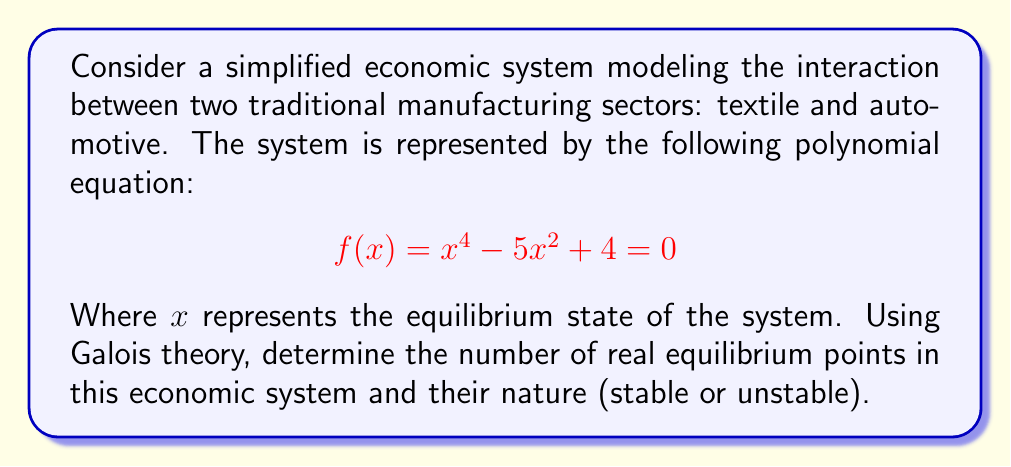Can you solve this math problem? To solve this problem using Galois theory, we'll follow these steps:

1) First, let's factor the polynomial:
   $$f(x) = x^4 - 5x^2 + 4 = (x^2 - 1)(x^2 - 4) = (x-1)(x+1)(x-2)(x+2)$$

2) The Galois group of this polynomial is a subgroup of $S_4$ (the symmetric group on 4 elements). Given the factorization, we can see that the Galois group is actually $C_2 \times C_2$, where $C_2$ is the cyclic group of order 2.

3) The fixed field of this Galois group is $\mathbb{Q}$, which means all roots are real and can be expressed using rational operations and square roots.

4) The roots of the polynomial are $x = \pm 1$ and $x = \pm 2$. These represent the equilibrium points of our economic system.

5) To determine stability, we need to consider the derivative of $f(x)$:
   $$f'(x) = 4x^3 - 10x$$

6) Evaluating $f'(x)$ at each equilibrium point:
   $f'(-2) = -32 + 20 = -12 < 0$
   $f'(-1) = -4 + 10 = 6 > 0$
   $f'(1) = 4 - 10 = -6 < 0$
   $f'(2) = 32 - 20 = 12 > 0$

7) In economic systems, equilibrium points where $f'(x) < 0$ are typically stable, while those where $f'(x) > 0$ are unstable.

Therefore, we have four real equilibrium points: two stable ($x = -2$ and $x = 1$) and two unstable ($x = -1$ and $x = 2$).
Answer: 4 real equilibrium points: 2 stable ($x = -2, 1$) and 2 unstable ($x = -1, 2$) 